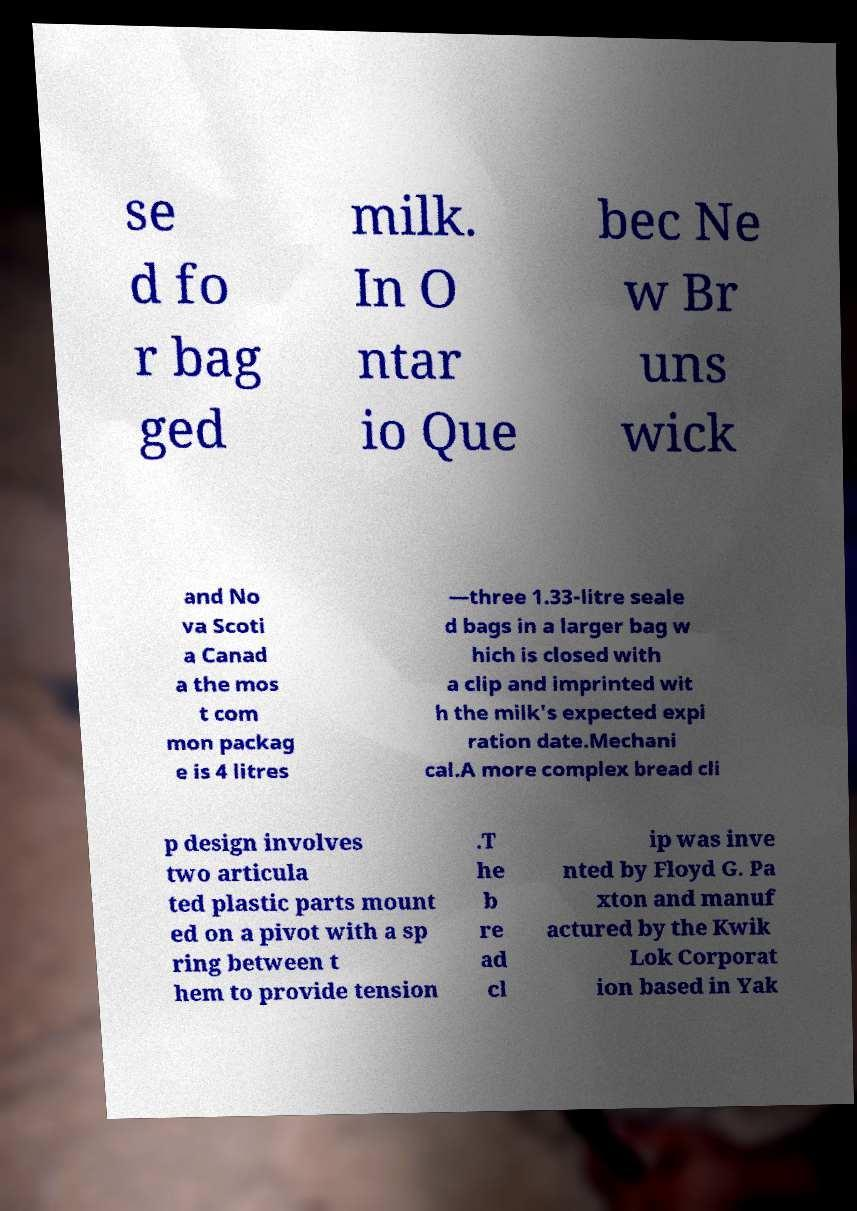I need the written content from this picture converted into text. Can you do that? se d fo r bag ged milk. In O ntar io Que bec Ne w Br uns wick and No va Scoti a Canad a the mos t com mon packag e is 4 litres —three 1.33-litre seale d bags in a larger bag w hich is closed with a clip and imprinted wit h the milk's expected expi ration date.Mechani cal.A more complex bread cli p design involves two articula ted plastic parts mount ed on a pivot with a sp ring between t hem to provide tension .T he b re ad cl ip was inve nted by Floyd G. Pa xton and manuf actured by the Kwik Lok Corporat ion based in Yak 